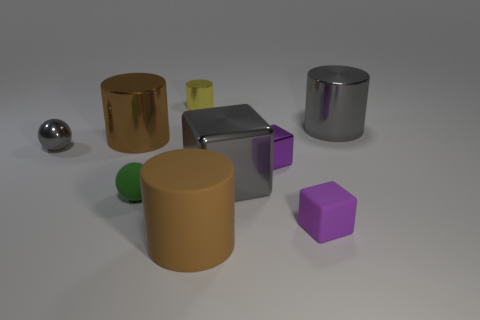Can you describe the lighting direction in the scene? The lighting in the scene appears to come from the upper right corner, casting shadows towards the lower left, which suggests a single, angled light source. 